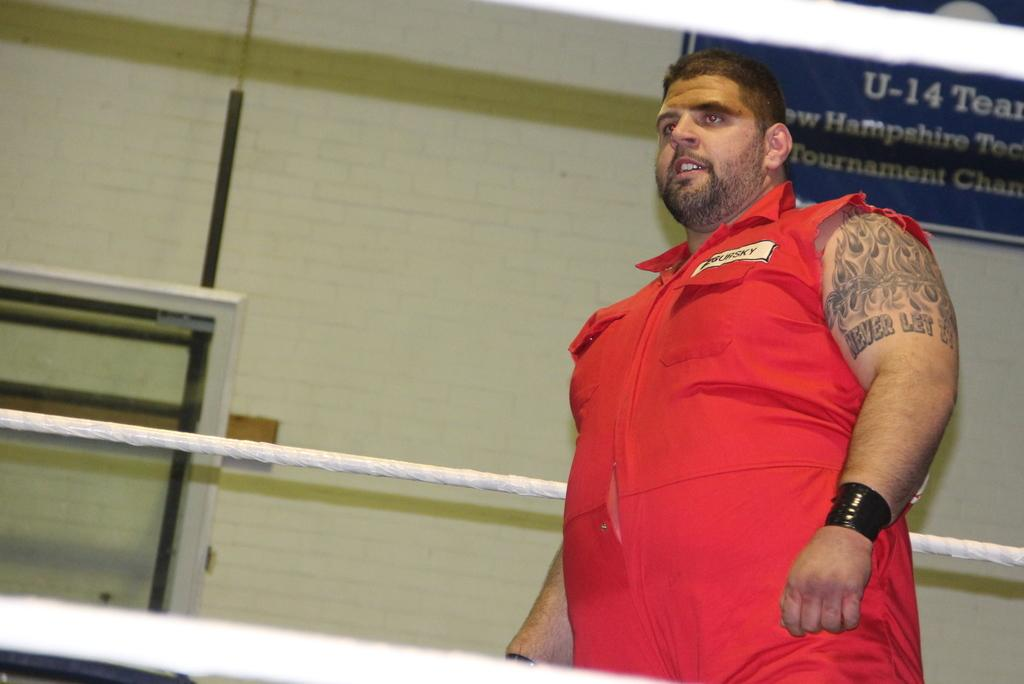<image>
Summarize the visual content of the image. A large man in a red jumpsuit has a tatoo that begins with never let it. 